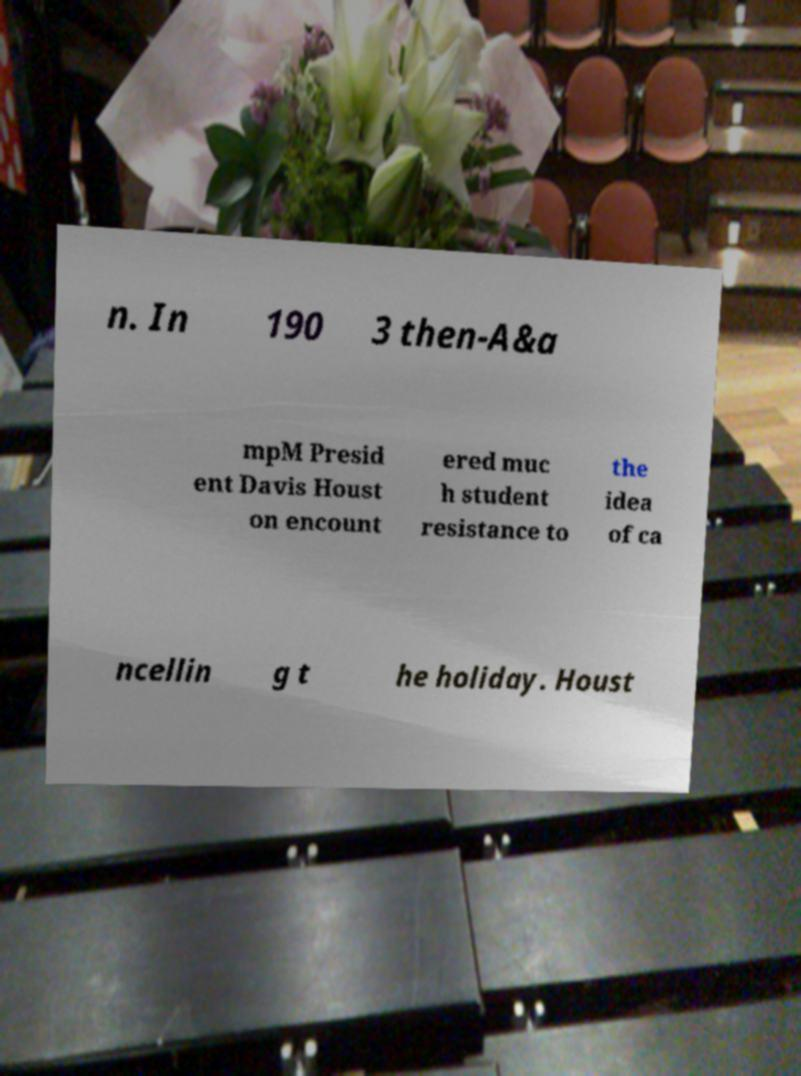Could you extract and type out the text from this image? n. In 190 3 then-A&a mpM Presid ent Davis Houst on encount ered muc h student resistance to the idea of ca ncellin g t he holiday. Houst 